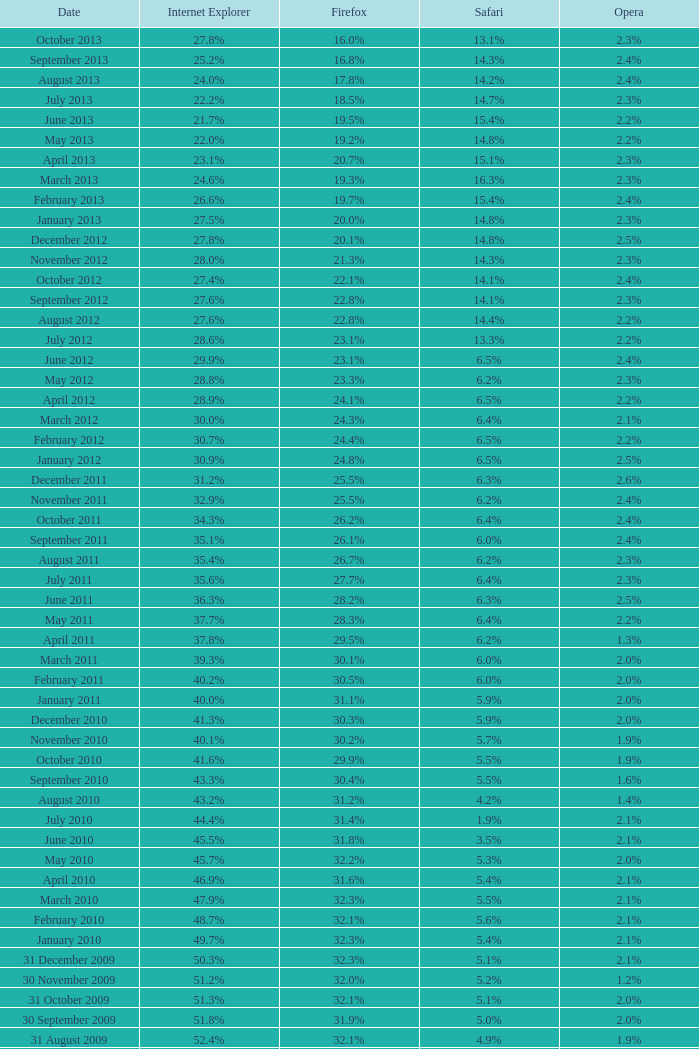What is the firefox value with a 1.8% opera on 30 July 2007? 25.1%. 